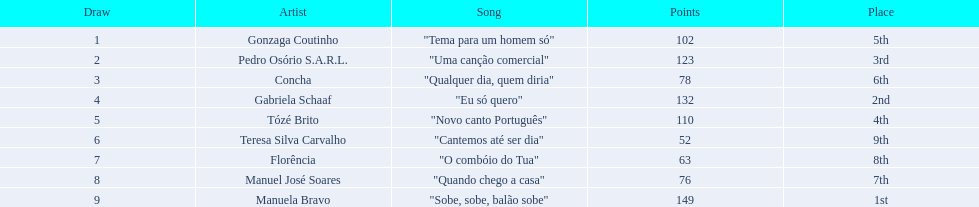In the contest, which song came in second place? "Eu só quero". Who was the artist behind "eu so quero"? Gabriela Schaaf. 